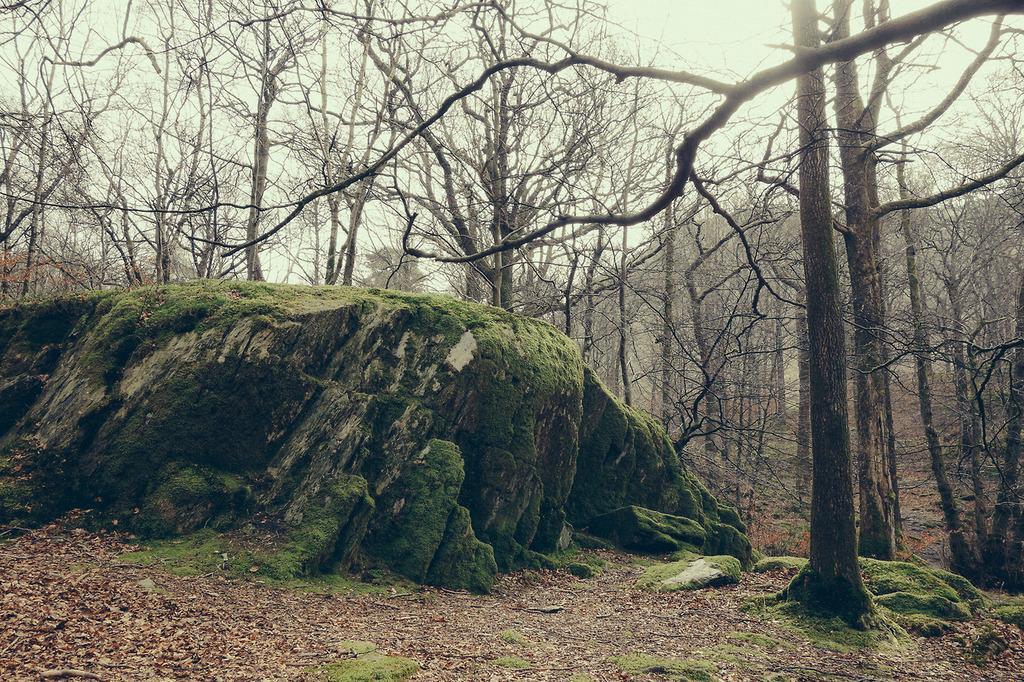How would you summarize this image in a sentence or two? This image is clicked in a forest. In the front, there is a rock. At the bottom, there is a ground. In the background, there are trees. 